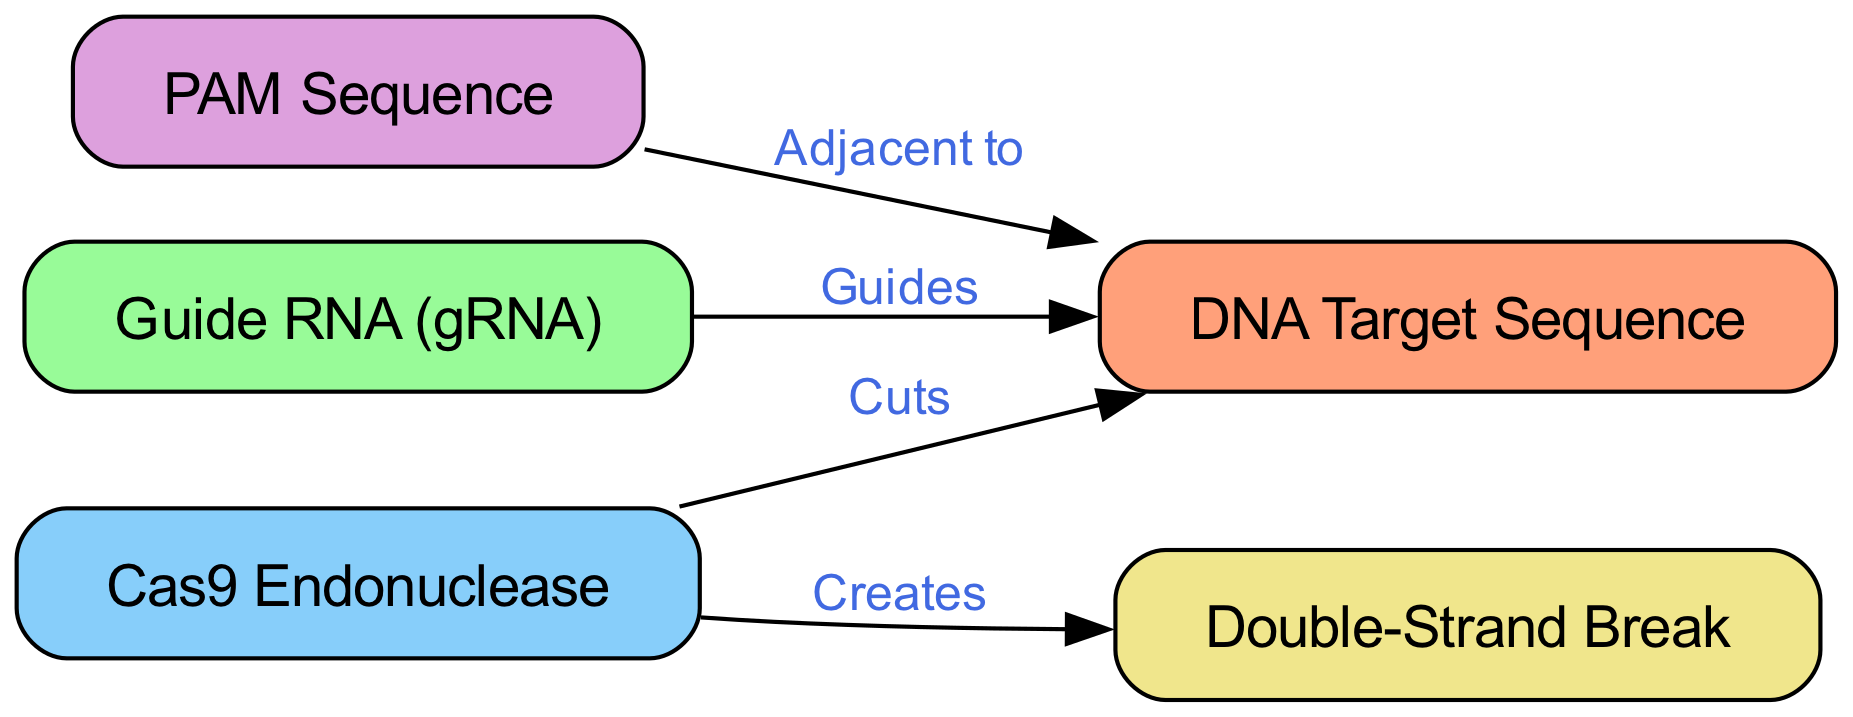What are the major components in the CRISPR-Cas9 system? The major components identified in the diagram include DNA Target Sequence, Guide RNA (gRNA), Cas9 Endonuclease, PAM Sequence, and Double-Strand Break. Each component is listed explicitly in the nodes section of the diagram.
Answer: DNA Target Sequence, Guide RNA (gRNA), Cas9 Endonuclease, PAM Sequence, Double-Strand Break How many nodes are in the diagram? The diagram contains five nodes representing different components of the CRISPR-Cas9 system. This can be determined by counting the entries in the nodes section of the provided data.
Answer: 5 Which component guides the editing process? The Guide RNA (gRNA) is the component that guides the Cas9 Endonuclease to the specific DNA Target Sequence for editing, as indicated by the edge labeled "Guides."
Answer: Guide RNA (gRNA) What does the Cas9 Endonuclease create? The Cas9 Endonuclease creates a Double-Strand Break in the DNA Target Sequence, which is explicitly labeled by the edge "Creates" in the diagram.
Answer: Double-Strand Break What is adjacent to the DNA Target Sequence? The PAM Sequence is adjacent to the DNA Target Sequence, as shown by the edge labeled "Adjacent to" connecting these two nodes.
Answer: PAM Sequence What relationship does the Cas9 Endonuclease have with the DNA Target Sequence? The Cas9 Endonuclease "Cuts" the DNA Target Sequence, as indicated by the labeled edge connecting the Cas9 Endonuclease and the DNA Target Sequence in the diagram.
Answer: Cuts How many edges are there in the diagram? There are four edges in the diagram, which can be counted from the edges section of the provided data that link the different components together.
Answer: 4 Why is the PAM Sequence important in the CRISPR-Cas9 system? The PAM Sequence is crucial because it is necessary for the Cas9 Endonuclease to bind to the DNA Target Sequence, as indicated by its relationship being "Adjacent to." Without this sequence, the Cas9 cannot effectively edit the target DNA.
Answer: Important for binding Which component initiates the gene editing? The Guide RNA (gRNA) initiates the gene editing process by guiding the Cas9 Endonuclease to the specific location on the DNA Target Sequence, as represented by the edges in the diagram that show its role.
Answer: Guide RNA (gRNA) 